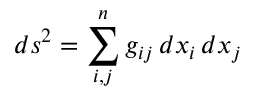<formula> <loc_0><loc_0><loc_500><loc_500>d s ^ { 2 } = \sum _ { i , j } ^ { n } g _ { i j } \, d x _ { i } \, d x _ { j }</formula> 